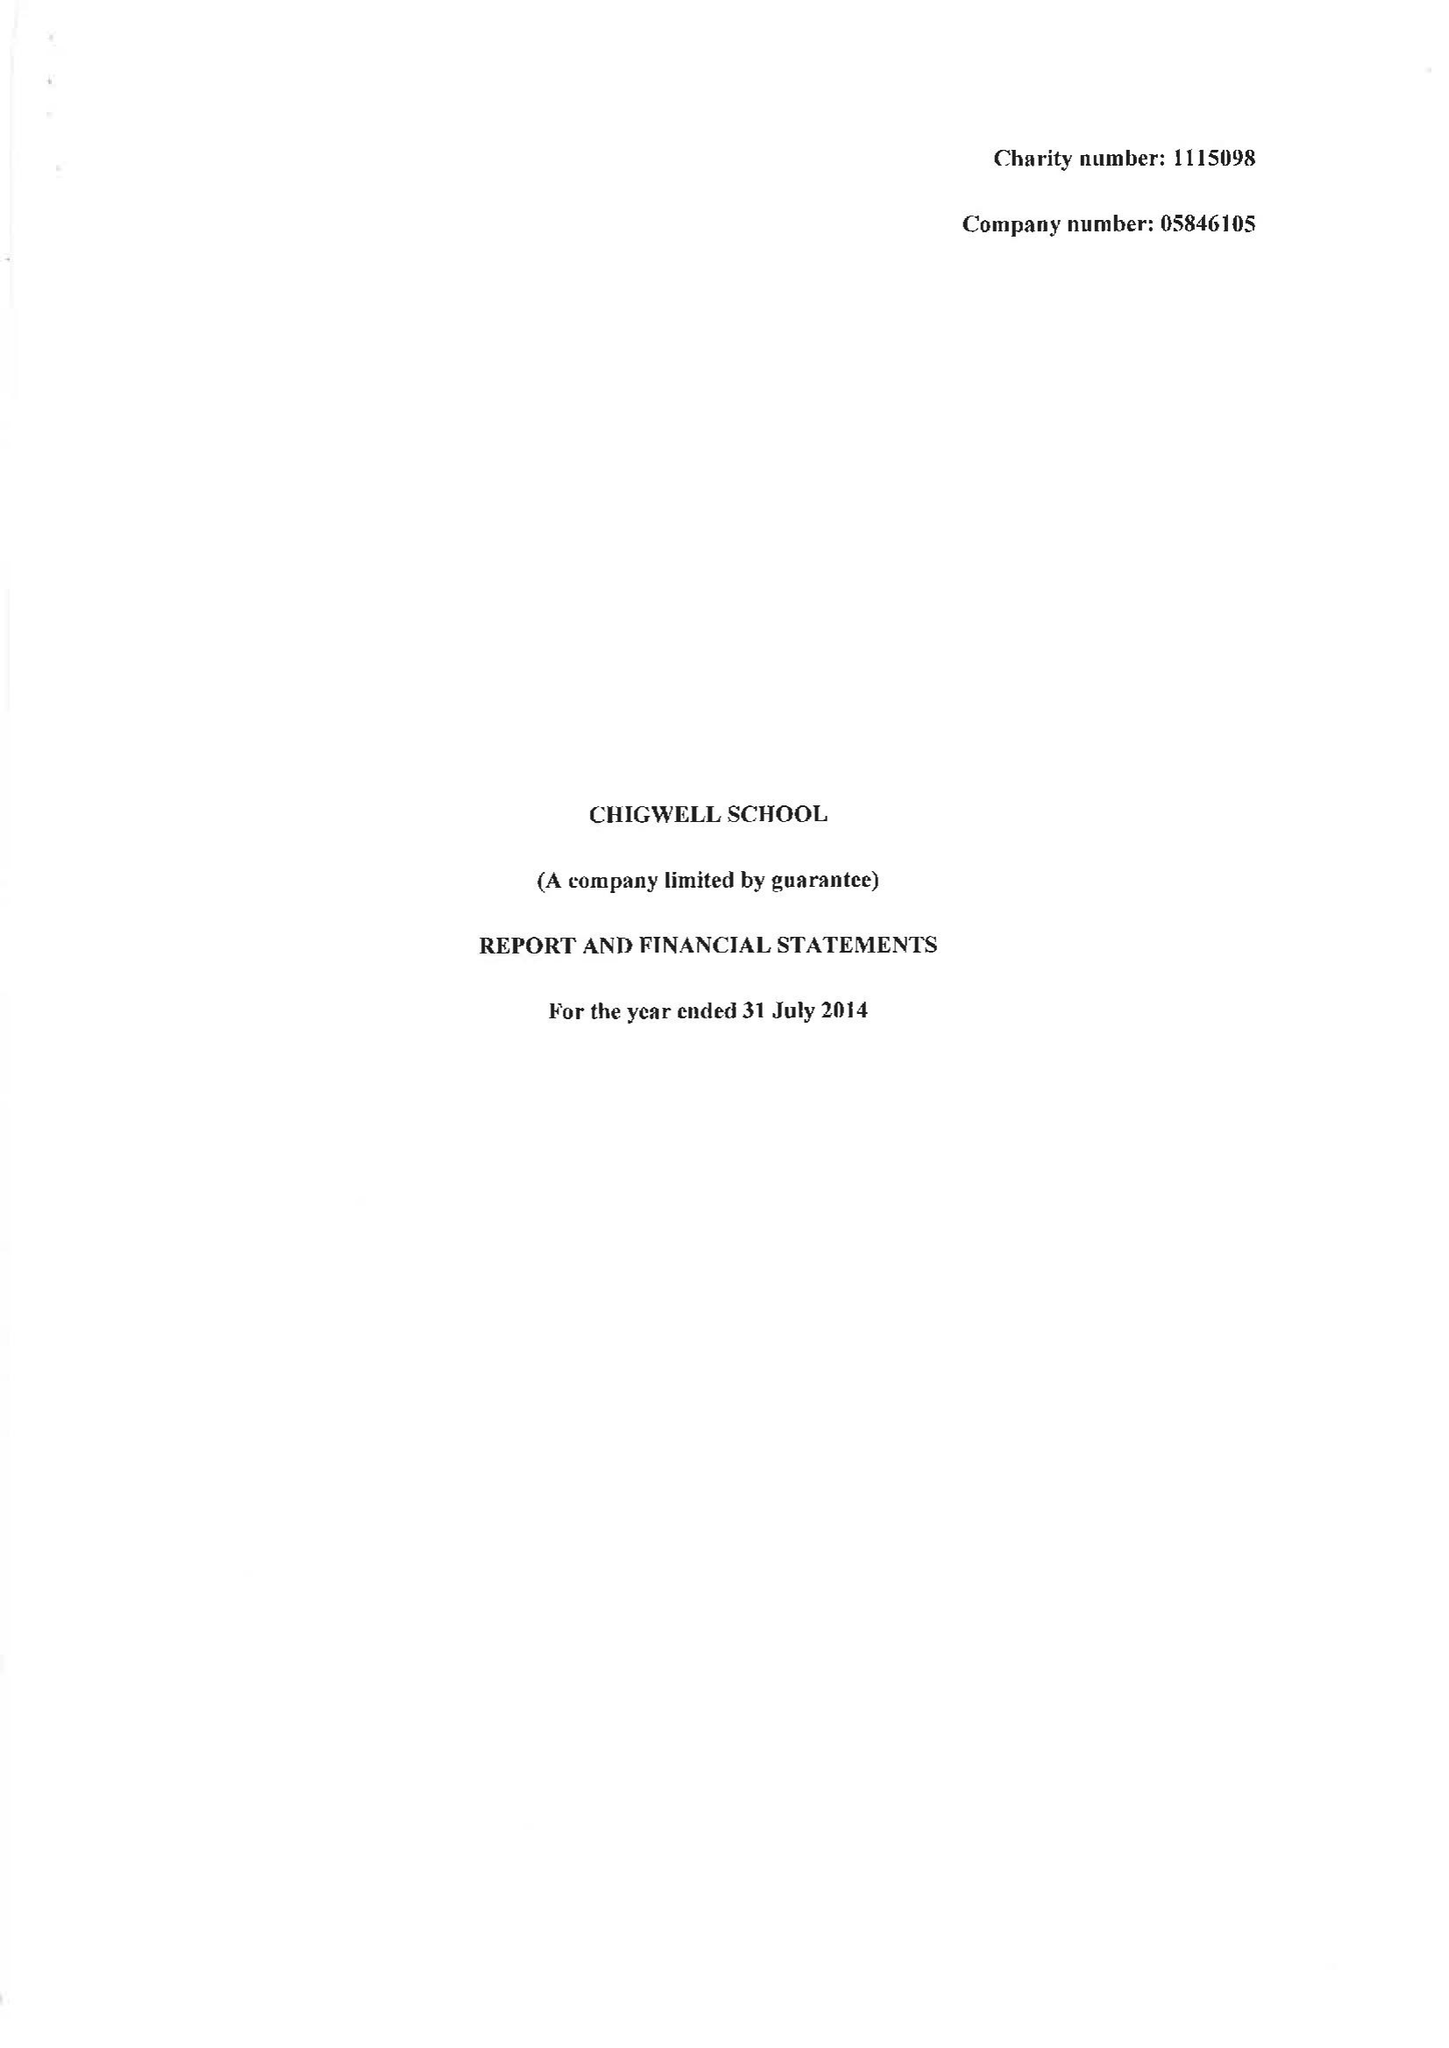What is the value for the address__postcode?
Answer the question using a single word or phrase. IG7 6QF 